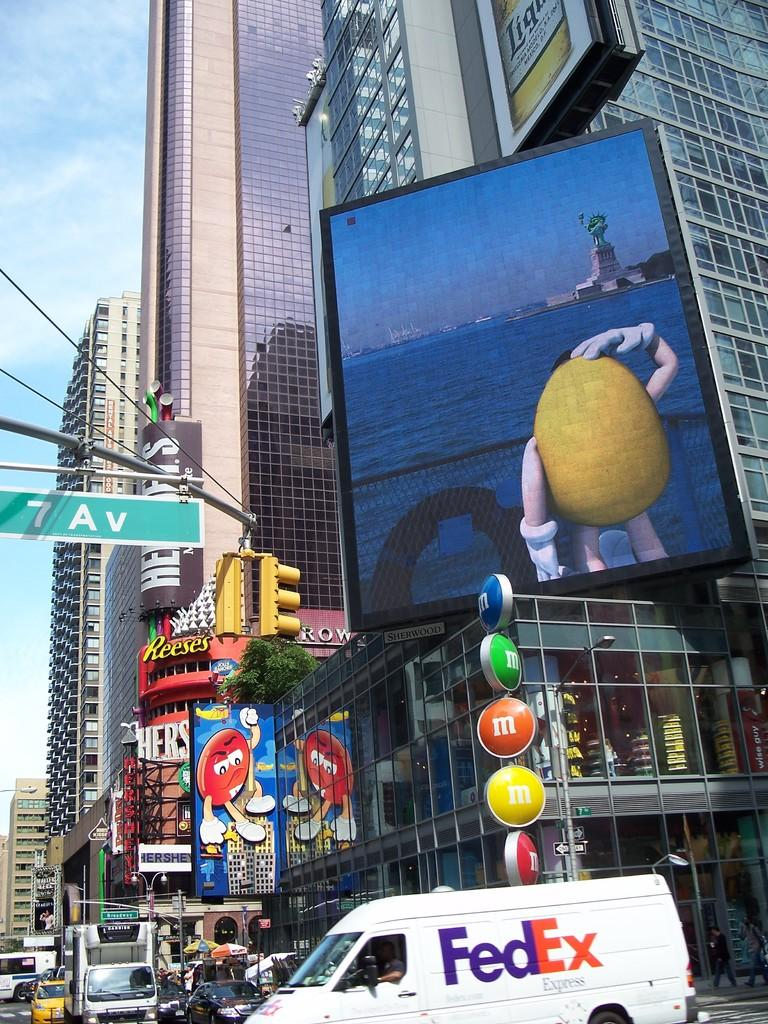<image>
Summarize the visual content of the image. A busy street in front of an M&Ms store. 